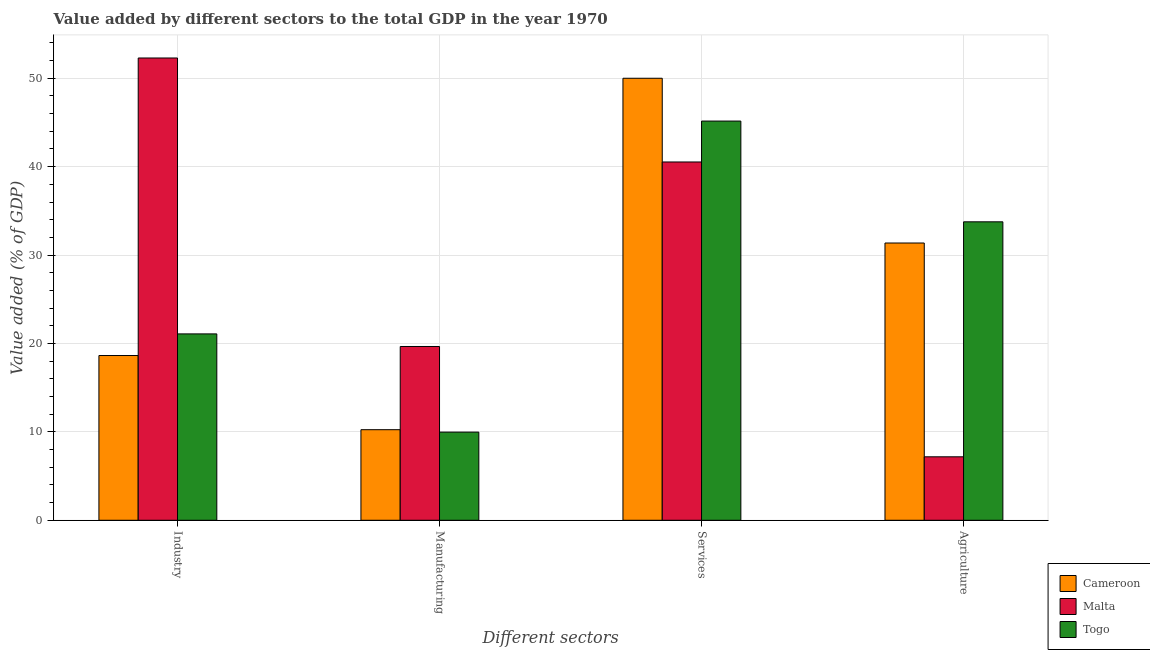How many different coloured bars are there?
Make the answer very short. 3. Are the number of bars per tick equal to the number of legend labels?
Keep it short and to the point. Yes. Are the number of bars on each tick of the X-axis equal?
Offer a very short reply. Yes. What is the label of the 3rd group of bars from the left?
Your answer should be compact. Services. What is the value added by services sector in Malta?
Offer a very short reply. 40.53. Across all countries, what is the minimum value added by services sector?
Offer a very short reply. 40.53. In which country was the value added by agricultural sector maximum?
Provide a succinct answer. Togo. In which country was the value added by agricultural sector minimum?
Offer a terse response. Malta. What is the total value added by manufacturing sector in the graph?
Provide a short and direct response. 39.87. What is the difference between the value added by agricultural sector in Togo and that in Malta?
Your response must be concise. 26.58. What is the difference between the value added by industrial sector in Togo and the value added by manufacturing sector in Malta?
Your response must be concise. 1.43. What is the average value added by services sector per country?
Your response must be concise. 45.23. What is the difference between the value added by services sector and value added by industrial sector in Cameroon?
Make the answer very short. 31.36. In how many countries, is the value added by industrial sector greater than 46 %?
Provide a succinct answer. 1. What is the ratio of the value added by manufacturing sector in Togo to that in Malta?
Make the answer very short. 0.51. Is the value added by agricultural sector in Togo less than that in Malta?
Make the answer very short. No. What is the difference between the highest and the second highest value added by agricultural sector?
Keep it short and to the point. 2.4. What is the difference between the highest and the lowest value added by services sector?
Keep it short and to the point. 9.47. In how many countries, is the value added by industrial sector greater than the average value added by industrial sector taken over all countries?
Keep it short and to the point. 1. Is the sum of the value added by services sector in Cameroon and Togo greater than the maximum value added by manufacturing sector across all countries?
Provide a succinct answer. Yes. What does the 3rd bar from the left in Services represents?
Ensure brevity in your answer.  Togo. What does the 3rd bar from the right in Industry represents?
Offer a terse response. Cameroon. How many bars are there?
Make the answer very short. 12. What is the difference between two consecutive major ticks on the Y-axis?
Give a very brief answer. 10. Are the values on the major ticks of Y-axis written in scientific E-notation?
Your response must be concise. No. Where does the legend appear in the graph?
Provide a succinct answer. Bottom right. What is the title of the graph?
Offer a terse response. Value added by different sectors to the total GDP in the year 1970. Does "Small states" appear as one of the legend labels in the graph?
Make the answer very short. No. What is the label or title of the X-axis?
Your response must be concise. Different sectors. What is the label or title of the Y-axis?
Provide a succinct answer. Value added (% of GDP). What is the Value added (% of GDP) in Cameroon in Industry?
Your answer should be compact. 18.64. What is the Value added (% of GDP) in Malta in Industry?
Your answer should be compact. 52.29. What is the Value added (% of GDP) in Togo in Industry?
Make the answer very short. 21.08. What is the Value added (% of GDP) of Cameroon in Manufacturing?
Give a very brief answer. 10.25. What is the Value added (% of GDP) in Malta in Manufacturing?
Offer a very short reply. 19.66. What is the Value added (% of GDP) in Togo in Manufacturing?
Your answer should be very brief. 9.97. What is the Value added (% of GDP) of Malta in Services?
Your answer should be compact. 40.53. What is the Value added (% of GDP) of Togo in Services?
Your answer should be very brief. 45.16. What is the Value added (% of GDP) of Cameroon in Agriculture?
Your response must be concise. 31.36. What is the Value added (% of GDP) of Malta in Agriculture?
Offer a terse response. 7.18. What is the Value added (% of GDP) in Togo in Agriculture?
Keep it short and to the point. 33.76. Across all Different sectors, what is the maximum Value added (% of GDP) of Malta?
Offer a very short reply. 52.29. Across all Different sectors, what is the maximum Value added (% of GDP) in Togo?
Give a very brief answer. 45.16. Across all Different sectors, what is the minimum Value added (% of GDP) in Cameroon?
Offer a very short reply. 10.25. Across all Different sectors, what is the minimum Value added (% of GDP) of Malta?
Offer a terse response. 7.18. Across all Different sectors, what is the minimum Value added (% of GDP) of Togo?
Your answer should be compact. 9.97. What is the total Value added (% of GDP) of Cameroon in the graph?
Give a very brief answer. 110.25. What is the total Value added (% of GDP) of Malta in the graph?
Offer a very short reply. 119.66. What is the total Value added (% of GDP) in Togo in the graph?
Your answer should be very brief. 109.97. What is the difference between the Value added (% of GDP) of Cameroon in Industry and that in Manufacturing?
Keep it short and to the point. 8.39. What is the difference between the Value added (% of GDP) in Malta in Industry and that in Manufacturing?
Keep it short and to the point. 32.64. What is the difference between the Value added (% of GDP) in Togo in Industry and that in Manufacturing?
Offer a terse response. 11.11. What is the difference between the Value added (% of GDP) in Cameroon in Industry and that in Services?
Provide a succinct answer. -31.36. What is the difference between the Value added (% of GDP) in Malta in Industry and that in Services?
Ensure brevity in your answer.  11.76. What is the difference between the Value added (% of GDP) in Togo in Industry and that in Services?
Ensure brevity in your answer.  -24.07. What is the difference between the Value added (% of GDP) of Cameroon in Industry and that in Agriculture?
Your answer should be compact. -12.73. What is the difference between the Value added (% of GDP) of Malta in Industry and that in Agriculture?
Offer a terse response. 45.11. What is the difference between the Value added (% of GDP) of Togo in Industry and that in Agriculture?
Your answer should be compact. -12.68. What is the difference between the Value added (% of GDP) of Cameroon in Manufacturing and that in Services?
Your answer should be very brief. -39.75. What is the difference between the Value added (% of GDP) of Malta in Manufacturing and that in Services?
Your response must be concise. -20.87. What is the difference between the Value added (% of GDP) of Togo in Manufacturing and that in Services?
Provide a short and direct response. -35.19. What is the difference between the Value added (% of GDP) in Cameroon in Manufacturing and that in Agriculture?
Provide a short and direct response. -21.12. What is the difference between the Value added (% of GDP) in Malta in Manufacturing and that in Agriculture?
Provide a short and direct response. 12.48. What is the difference between the Value added (% of GDP) in Togo in Manufacturing and that in Agriculture?
Provide a short and direct response. -23.79. What is the difference between the Value added (% of GDP) in Cameroon in Services and that in Agriculture?
Your response must be concise. 18.64. What is the difference between the Value added (% of GDP) in Malta in Services and that in Agriculture?
Your response must be concise. 33.35. What is the difference between the Value added (% of GDP) of Togo in Services and that in Agriculture?
Offer a terse response. 11.4. What is the difference between the Value added (% of GDP) of Cameroon in Industry and the Value added (% of GDP) of Malta in Manufacturing?
Your answer should be compact. -1.02. What is the difference between the Value added (% of GDP) of Cameroon in Industry and the Value added (% of GDP) of Togo in Manufacturing?
Make the answer very short. 8.66. What is the difference between the Value added (% of GDP) of Malta in Industry and the Value added (% of GDP) of Togo in Manufacturing?
Offer a terse response. 42.32. What is the difference between the Value added (% of GDP) in Cameroon in Industry and the Value added (% of GDP) in Malta in Services?
Offer a very short reply. -21.89. What is the difference between the Value added (% of GDP) in Cameroon in Industry and the Value added (% of GDP) in Togo in Services?
Your answer should be very brief. -26.52. What is the difference between the Value added (% of GDP) in Malta in Industry and the Value added (% of GDP) in Togo in Services?
Provide a succinct answer. 7.14. What is the difference between the Value added (% of GDP) in Cameroon in Industry and the Value added (% of GDP) in Malta in Agriculture?
Make the answer very short. 11.46. What is the difference between the Value added (% of GDP) of Cameroon in Industry and the Value added (% of GDP) of Togo in Agriculture?
Keep it short and to the point. -15.12. What is the difference between the Value added (% of GDP) of Malta in Industry and the Value added (% of GDP) of Togo in Agriculture?
Offer a very short reply. 18.53. What is the difference between the Value added (% of GDP) in Cameroon in Manufacturing and the Value added (% of GDP) in Malta in Services?
Give a very brief answer. -30.28. What is the difference between the Value added (% of GDP) in Cameroon in Manufacturing and the Value added (% of GDP) in Togo in Services?
Your answer should be compact. -34.91. What is the difference between the Value added (% of GDP) in Malta in Manufacturing and the Value added (% of GDP) in Togo in Services?
Ensure brevity in your answer.  -25.5. What is the difference between the Value added (% of GDP) of Cameroon in Manufacturing and the Value added (% of GDP) of Malta in Agriculture?
Keep it short and to the point. 3.07. What is the difference between the Value added (% of GDP) of Cameroon in Manufacturing and the Value added (% of GDP) of Togo in Agriculture?
Offer a very short reply. -23.52. What is the difference between the Value added (% of GDP) of Malta in Manufacturing and the Value added (% of GDP) of Togo in Agriculture?
Provide a short and direct response. -14.1. What is the difference between the Value added (% of GDP) of Cameroon in Services and the Value added (% of GDP) of Malta in Agriculture?
Provide a succinct answer. 42.82. What is the difference between the Value added (% of GDP) in Cameroon in Services and the Value added (% of GDP) in Togo in Agriculture?
Make the answer very short. 16.24. What is the difference between the Value added (% of GDP) of Malta in Services and the Value added (% of GDP) of Togo in Agriculture?
Your response must be concise. 6.77. What is the average Value added (% of GDP) in Cameroon per Different sectors?
Offer a terse response. 27.56. What is the average Value added (% of GDP) of Malta per Different sectors?
Make the answer very short. 29.91. What is the average Value added (% of GDP) in Togo per Different sectors?
Provide a succinct answer. 27.49. What is the difference between the Value added (% of GDP) in Cameroon and Value added (% of GDP) in Malta in Industry?
Provide a short and direct response. -33.66. What is the difference between the Value added (% of GDP) of Cameroon and Value added (% of GDP) of Togo in Industry?
Your answer should be compact. -2.45. What is the difference between the Value added (% of GDP) in Malta and Value added (% of GDP) in Togo in Industry?
Provide a succinct answer. 31.21. What is the difference between the Value added (% of GDP) of Cameroon and Value added (% of GDP) of Malta in Manufacturing?
Make the answer very short. -9.41. What is the difference between the Value added (% of GDP) in Cameroon and Value added (% of GDP) in Togo in Manufacturing?
Provide a succinct answer. 0.27. What is the difference between the Value added (% of GDP) of Malta and Value added (% of GDP) of Togo in Manufacturing?
Provide a short and direct response. 9.69. What is the difference between the Value added (% of GDP) in Cameroon and Value added (% of GDP) in Malta in Services?
Your response must be concise. 9.47. What is the difference between the Value added (% of GDP) of Cameroon and Value added (% of GDP) of Togo in Services?
Provide a succinct answer. 4.84. What is the difference between the Value added (% of GDP) of Malta and Value added (% of GDP) of Togo in Services?
Offer a terse response. -4.63. What is the difference between the Value added (% of GDP) of Cameroon and Value added (% of GDP) of Malta in Agriculture?
Give a very brief answer. 24.19. What is the difference between the Value added (% of GDP) in Cameroon and Value added (% of GDP) in Togo in Agriculture?
Provide a short and direct response. -2.4. What is the difference between the Value added (% of GDP) of Malta and Value added (% of GDP) of Togo in Agriculture?
Make the answer very short. -26.58. What is the ratio of the Value added (% of GDP) in Cameroon in Industry to that in Manufacturing?
Offer a very short reply. 1.82. What is the ratio of the Value added (% of GDP) of Malta in Industry to that in Manufacturing?
Provide a short and direct response. 2.66. What is the ratio of the Value added (% of GDP) of Togo in Industry to that in Manufacturing?
Give a very brief answer. 2.11. What is the ratio of the Value added (% of GDP) of Cameroon in Industry to that in Services?
Ensure brevity in your answer.  0.37. What is the ratio of the Value added (% of GDP) in Malta in Industry to that in Services?
Your answer should be very brief. 1.29. What is the ratio of the Value added (% of GDP) of Togo in Industry to that in Services?
Offer a very short reply. 0.47. What is the ratio of the Value added (% of GDP) of Cameroon in Industry to that in Agriculture?
Give a very brief answer. 0.59. What is the ratio of the Value added (% of GDP) of Malta in Industry to that in Agriculture?
Your response must be concise. 7.28. What is the ratio of the Value added (% of GDP) in Togo in Industry to that in Agriculture?
Keep it short and to the point. 0.62. What is the ratio of the Value added (% of GDP) in Cameroon in Manufacturing to that in Services?
Ensure brevity in your answer.  0.2. What is the ratio of the Value added (% of GDP) of Malta in Manufacturing to that in Services?
Keep it short and to the point. 0.48. What is the ratio of the Value added (% of GDP) of Togo in Manufacturing to that in Services?
Keep it short and to the point. 0.22. What is the ratio of the Value added (% of GDP) in Cameroon in Manufacturing to that in Agriculture?
Your response must be concise. 0.33. What is the ratio of the Value added (% of GDP) of Malta in Manufacturing to that in Agriculture?
Offer a terse response. 2.74. What is the ratio of the Value added (% of GDP) in Togo in Manufacturing to that in Agriculture?
Offer a terse response. 0.3. What is the ratio of the Value added (% of GDP) of Cameroon in Services to that in Agriculture?
Provide a short and direct response. 1.59. What is the ratio of the Value added (% of GDP) in Malta in Services to that in Agriculture?
Your answer should be compact. 5.65. What is the ratio of the Value added (% of GDP) in Togo in Services to that in Agriculture?
Provide a short and direct response. 1.34. What is the difference between the highest and the second highest Value added (% of GDP) in Cameroon?
Provide a short and direct response. 18.64. What is the difference between the highest and the second highest Value added (% of GDP) in Malta?
Provide a short and direct response. 11.76. What is the difference between the highest and the second highest Value added (% of GDP) of Togo?
Your answer should be compact. 11.4. What is the difference between the highest and the lowest Value added (% of GDP) of Cameroon?
Offer a terse response. 39.75. What is the difference between the highest and the lowest Value added (% of GDP) of Malta?
Offer a terse response. 45.11. What is the difference between the highest and the lowest Value added (% of GDP) in Togo?
Provide a short and direct response. 35.19. 